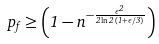Convert formula to latex. <formula><loc_0><loc_0><loc_500><loc_500>p _ { f } \geq \left ( 1 - n ^ { - \frac { \epsilon ^ { 2 } } { 2 \ln 2 \, ( 1 + \epsilon / 3 ) } } \right )</formula> 